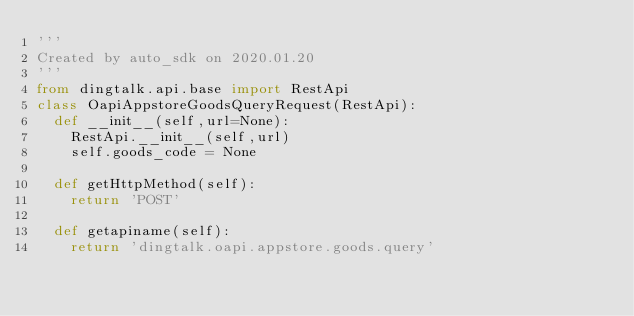Convert code to text. <code><loc_0><loc_0><loc_500><loc_500><_Python_>'''
Created by auto_sdk on 2020.01.20
'''
from dingtalk.api.base import RestApi
class OapiAppstoreGoodsQueryRequest(RestApi):
	def __init__(self,url=None):
		RestApi.__init__(self,url)
		self.goods_code = None

	def getHttpMethod(self):
		return 'POST'

	def getapiname(self):
		return 'dingtalk.oapi.appstore.goods.query'
</code> 